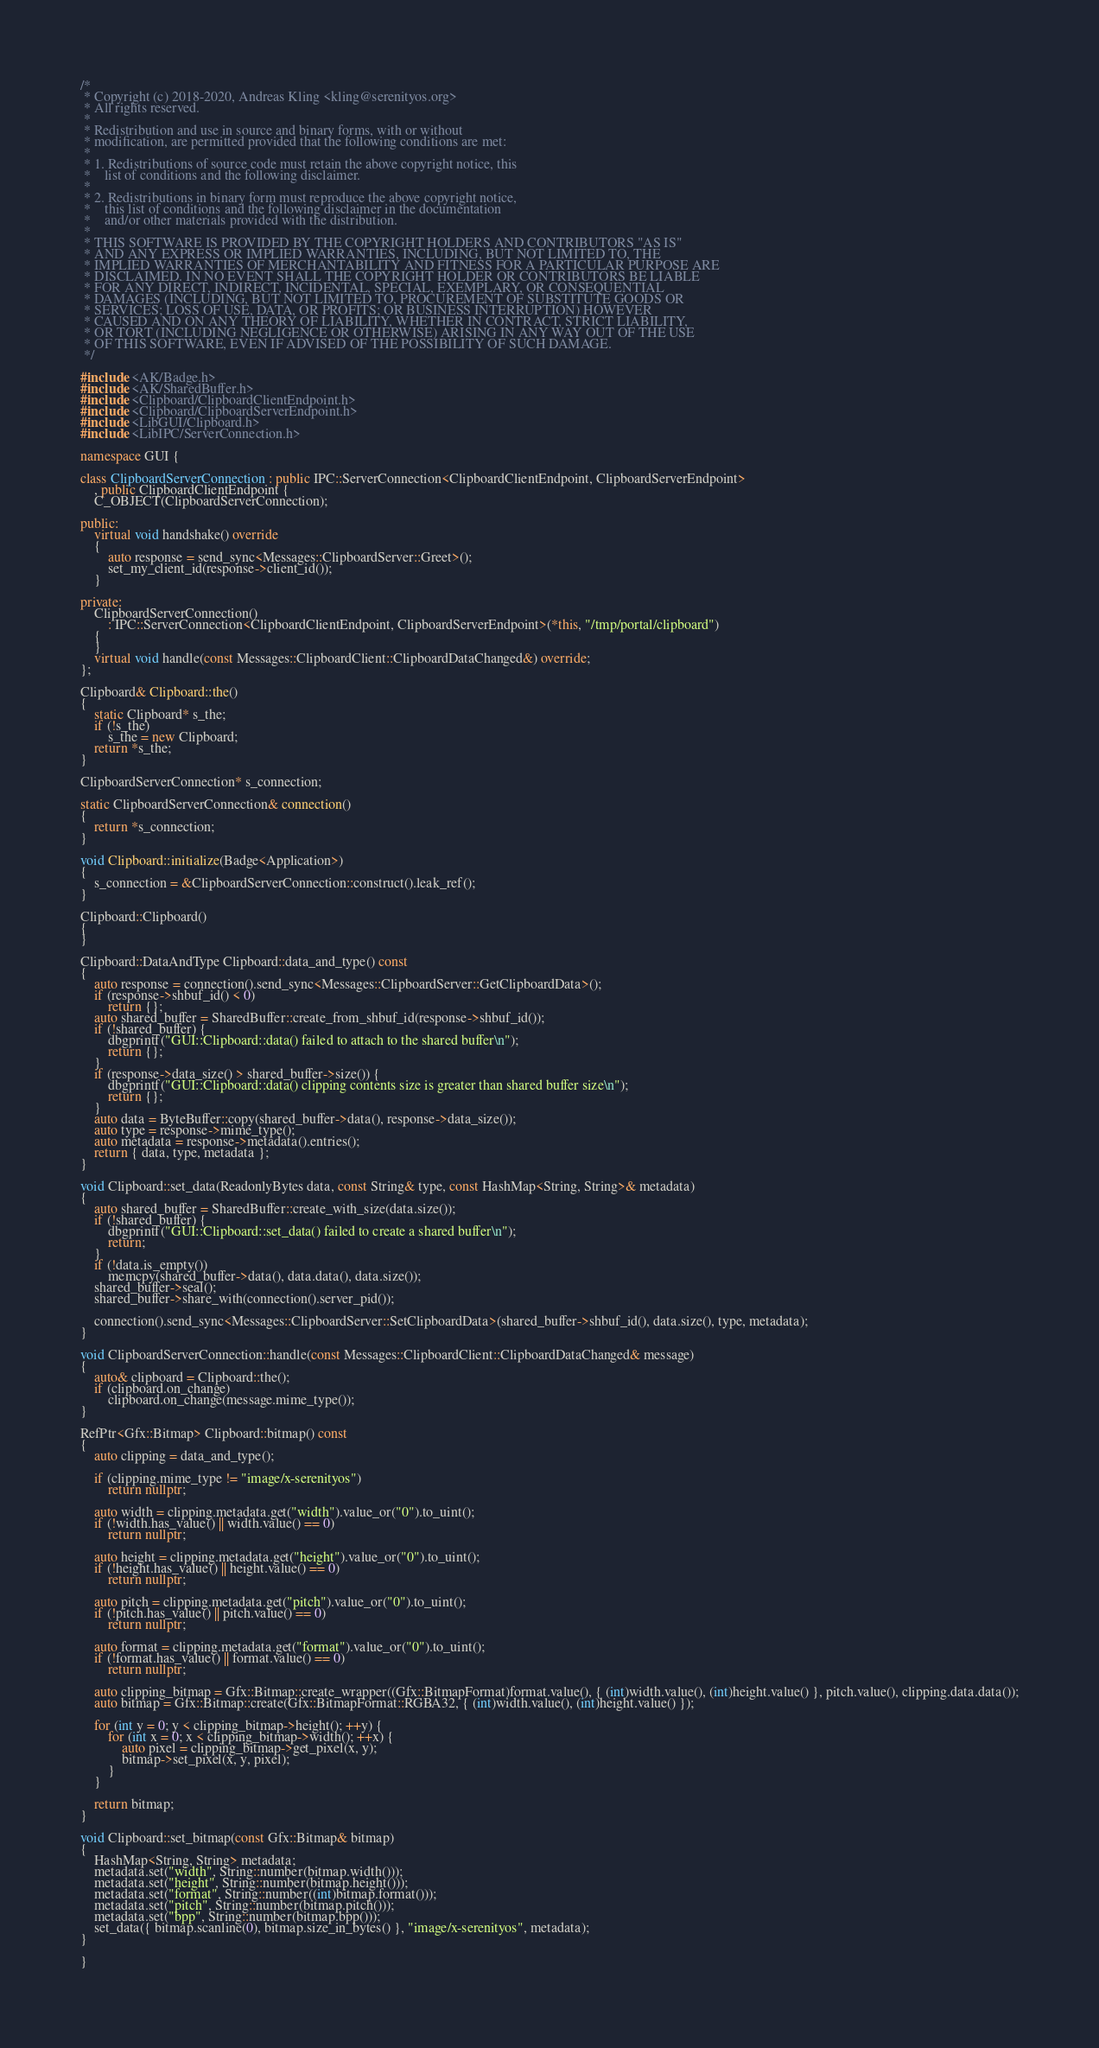<code> <loc_0><loc_0><loc_500><loc_500><_C++_>/*
 * Copyright (c) 2018-2020, Andreas Kling <kling@serenityos.org>
 * All rights reserved.
 *
 * Redistribution and use in source and binary forms, with or without
 * modification, are permitted provided that the following conditions are met:
 *
 * 1. Redistributions of source code must retain the above copyright notice, this
 *    list of conditions and the following disclaimer.
 *
 * 2. Redistributions in binary form must reproduce the above copyright notice,
 *    this list of conditions and the following disclaimer in the documentation
 *    and/or other materials provided with the distribution.
 *
 * THIS SOFTWARE IS PROVIDED BY THE COPYRIGHT HOLDERS AND CONTRIBUTORS "AS IS"
 * AND ANY EXPRESS OR IMPLIED WARRANTIES, INCLUDING, BUT NOT LIMITED TO, THE
 * IMPLIED WARRANTIES OF MERCHANTABILITY AND FITNESS FOR A PARTICULAR PURPOSE ARE
 * DISCLAIMED. IN NO EVENT SHALL THE COPYRIGHT HOLDER OR CONTRIBUTORS BE LIABLE
 * FOR ANY DIRECT, INDIRECT, INCIDENTAL, SPECIAL, EXEMPLARY, OR CONSEQUENTIAL
 * DAMAGES (INCLUDING, BUT NOT LIMITED TO, PROCUREMENT OF SUBSTITUTE GOODS OR
 * SERVICES; LOSS OF USE, DATA, OR PROFITS; OR BUSINESS INTERRUPTION) HOWEVER
 * CAUSED AND ON ANY THEORY OF LIABILITY, WHETHER IN CONTRACT, STRICT LIABILITY,
 * OR TORT (INCLUDING NEGLIGENCE OR OTHERWISE) ARISING IN ANY WAY OUT OF THE USE
 * OF THIS SOFTWARE, EVEN IF ADVISED OF THE POSSIBILITY OF SUCH DAMAGE.
 */

#include <AK/Badge.h>
#include <AK/SharedBuffer.h>
#include <Clipboard/ClipboardClientEndpoint.h>
#include <Clipboard/ClipboardServerEndpoint.h>
#include <LibGUI/Clipboard.h>
#include <LibIPC/ServerConnection.h>

namespace GUI {

class ClipboardServerConnection : public IPC::ServerConnection<ClipboardClientEndpoint, ClipboardServerEndpoint>
    , public ClipboardClientEndpoint {
    C_OBJECT(ClipboardServerConnection);

public:
    virtual void handshake() override
    {
        auto response = send_sync<Messages::ClipboardServer::Greet>();
        set_my_client_id(response->client_id());
    }

private:
    ClipboardServerConnection()
        : IPC::ServerConnection<ClipboardClientEndpoint, ClipboardServerEndpoint>(*this, "/tmp/portal/clipboard")
    {
    }
    virtual void handle(const Messages::ClipboardClient::ClipboardDataChanged&) override;
};

Clipboard& Clipboard::the()
{
    static Clipboard* s_the;
    if (!s_the)
        s_the = new Clipboard;
    return *s_the;
}

ClipboardServerConnection* s_connection;

static ClipboardServerConnection& connection()
{
    return *s_connection;
}

void Clipboard::initialize(Badge<Application>)
{
    s_connection = &ClipboardServerConnection::construct().leak_ref();
}

Clipboard::Clipboard()
{
}

Clipboard::DataAndType Clipboard::data_and_type() const
{
    auto response = connection().send_sync<Messages::ClipboardServer::GetClipboardData>();
    if (response->shbuf_id() < 0)
        return {};
    auto shared_buffer = SharedBuffer::create_from_shbuf_id(response->shbuf_id());
    if (!shared_buffer) {
        dbgprintf("GUI::Clipboard::data() failed to attach to the shared buffer\n");
        return {};
    }
    if (response->data_size() > shared_buffer->size()) {
        dbgprintf("GUI::Clipboard::data() clipping contents size is greater than shared buffer size\n");
        return {};
    }
    auto data = ByteBuffer::copy(shared_buffer->data(), response->data_size());
    auto type = response->mime_type();
    auto metadata = response->metadata().entries();
    return { data, type, metadata };
}

void Clipboard::set_data(ReadonlyBytes data, const String& type, const HashMap<String, String>& metadata)
{
    auto shared_buffer = SharedBuffer::create_with_size(data.size());
    if (!shared_buffer) {
        dbgprintf("GUI::Clipboard::set_data() failed to create a shared buffer\n");
        return;
    }
    if (!data.is_empty())
        memcpy(shared_buffer->data(), data.data(), data.size());
    shared_buffer->seal();
    shared_buffer->share_with(connection().server_pid());

    connection().send_sync<Messages::ClipboardServer::SetClipboardData>(shared_buffer->shbuf_id(), data.size(), type, metadata);
}

void ClipboardServerConnection::handle(const Messages::ClipboardClient::ClipboardDataChanged& message)
{
    auto& clipboard = Clipboard::the();
    if (clipboard.on_change)
        clipboard.on_change(message.mime_type());
}

RefPtr<Gfx::Bitmap> Clipboard::bitmap() const
{
    auto clipping = data_and_type();

    if (clipping.mime_type != "image/x-serenityos")
        return nullptr;

    auto width = clipping.metadata.get("width").value_or("0").to_uint();
    if (!width.has_value() || width.value() == 0)
        return nullptr;

    auto height = clipping.metadata.get("height").value_or("0").to_uint();
    if (!height.has_value() || height.value() == 0)
        return nullptr;

    auto pitch = clipping.metadata.get("pitch").value_or("0").to_uint();
    if (!pitch.has_value() || pitch.value() == 0)
        return nullptr;

    auto format = clipping.metadata.get("format").value_or("0").to_uint();
    if (!format.has_value() || format.value() == 0)
        return nullptr;

    auto clipping_bitmap = Gfx::Bitmap::create_wrapper((Gfx::BitmapFormat)format.value(), { (int)width.value(), (int)height.value() }, pitch.value(), clipping.data.data());
    auto bitmap = Gfx::Bitmap::create(Gfx::BitmapFormat::RGBA32, { (int)width.value(), (int)height.value() });

    for (int y = 0; y < clipping_bitmap->height(); ++y) {
        for (int x = 0; x < clipping_bitmap->width(); ++x) {
            auto pixel = clipping_bitmap->get_pixel(x, y);
            bitmap->set_pixel(x, y, pixel);
        }
    }

    return bitmap;
}

void Clipboard::set_bitmap(const Gfx::Bitmap& bitmap)
{
    HashMap<String, String> metadata;
    metadata.set("width", String::number(bitmap.width()));
    metadata.set("height", String::number(bitmap.height()));
    metadata.set("format", String::number((int)bitmap.format()));
    metadata.set("pitch", String::number(bitmap.pitch()));
    metadata.set("bpp", String::number(bitmap.bpp()));
    set_data({ bitmap.scanline(0), bitmap.size_in_bytes() }, "image/x-serenityos", metadata);
}

}
</code> 